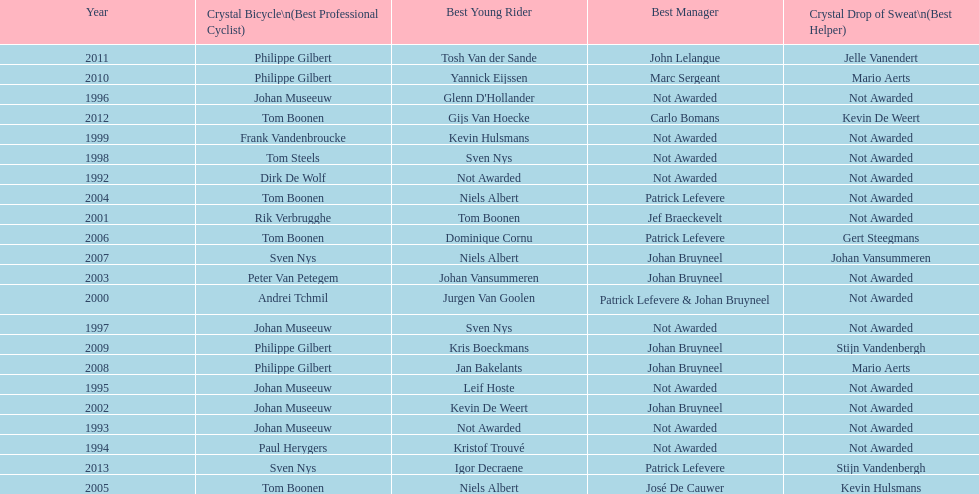What is the total number of times johan bryneel's name appears on all of these lists? 6. 